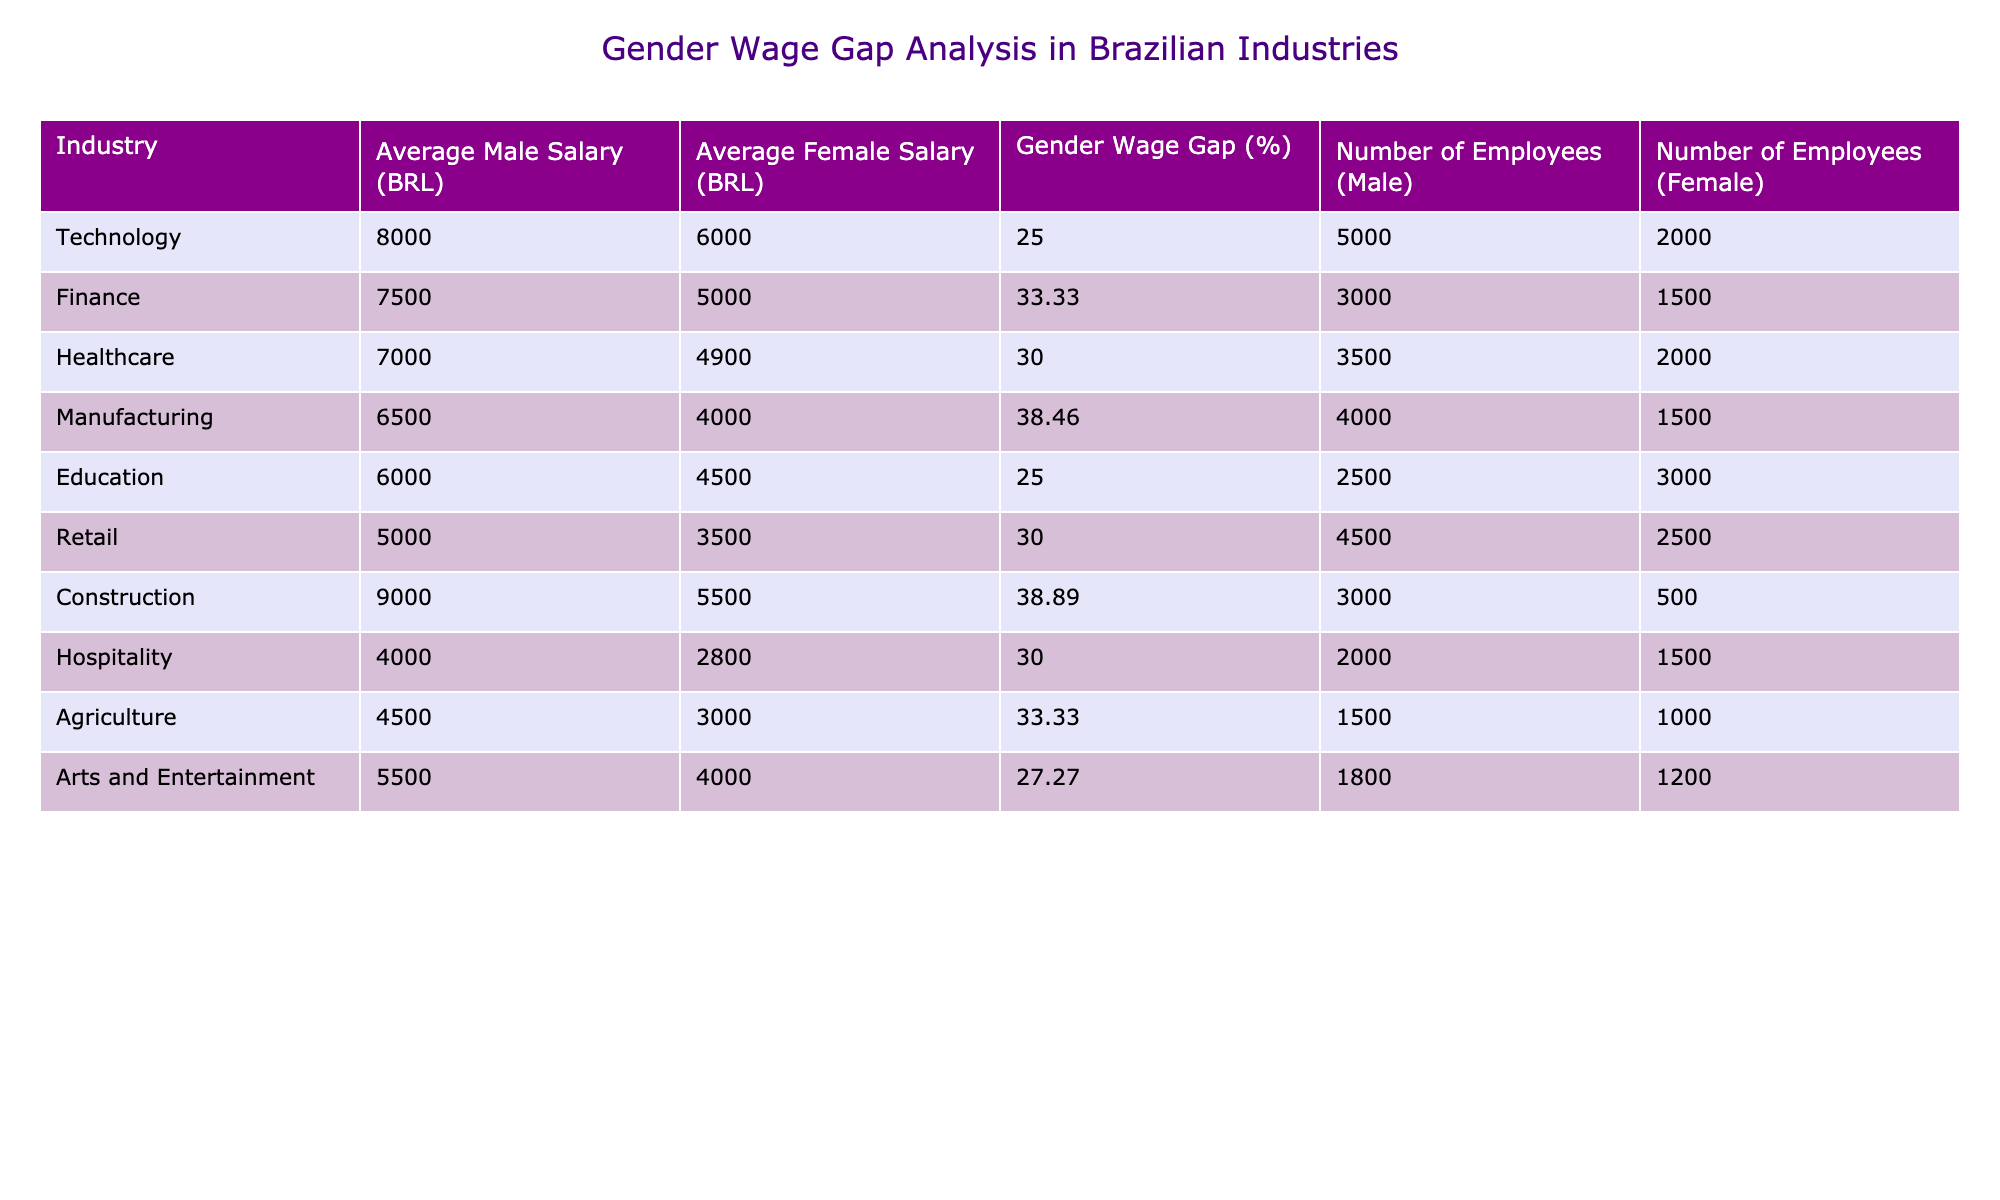What is the gender wage gap percentage in the Finance industry? The data for the Finance industry shows that the gender wage gap is 33.33%. It is listed directly in the table under the Gender Wage Gap (%) column for that industry.
Answer: 33.33 Which industry has the highest average male salary? The highest average male salary is found in the Construction industry at 9000 BRL. This is compared to the other entries in the Average Male Salary (BRL) column in the table.
Answer: 9000 What is the average female salary in the Education industry? In the Education industry, the average female salary is 4500 BRL. This figure can be found directly in the Average Female Salary (BRL) column corresponding to the Education row.
Answer: 4500 Is the average female salary in the Retail industry higher than in the Hospitality industry? The average female salary in Retail is 3500 BRL, while in Hospitality, it is 2800 BRL. Since 3500 is greater than 2800, the answer is yes.
Answer: Yes What is the difference between the average male salary and the average female salary in the Arts and Entertainment industry? The average male salary in Arts and Entertainment is 5500 BRL, and the average female salary is 4000 BRL. The difference is calculated as 5500 - 4000 = 1500 BRL.
Answer: 1500 Which industry has a gender wage gap of 30%? The industries with a gender wage gap of 30% are Healthcare, Retail, and Hospitality. Each gap can be confirmed from the Gender Wage Gap (%) column.
Answer: Healthcare, Retail, Hospitality Calculate the total number of female employees across all industries. Summing the female employees: 2000 (Tech) + 1500 (Finance) + 2000 (Healthcare) + 1500 (Manufacturing) + 3000 (Education) + 2500 (Retail) + 500 (Construction) + 1500 (Hospitality) + 1000 (Agriculture) + 1200 (Arts) gives a total of 14700.
Answer: 14700 Which industry has the largest number of male employees? The Technology industry has the largest number of male employees, with 5000. This can be identified by scanning through the Number of Employees (Male) column for the highest value.
Answer: 5000 What is the average gender wage gap percentage across all industries? First, sum the gender wage gap percentages: 25 + 33.33 + 30 + 38.46 + 25 + 30 + 38.89 + 30 + 33.33 + 27.27 =  338.65. Then divide by the number of industries (10): 338.65 / 10 = 33.865%.
Answer: 33.87 (approx.) 